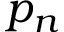<formula> <loc_0><loc_0><loc_500><loc_500>p _ { n }</formula> 